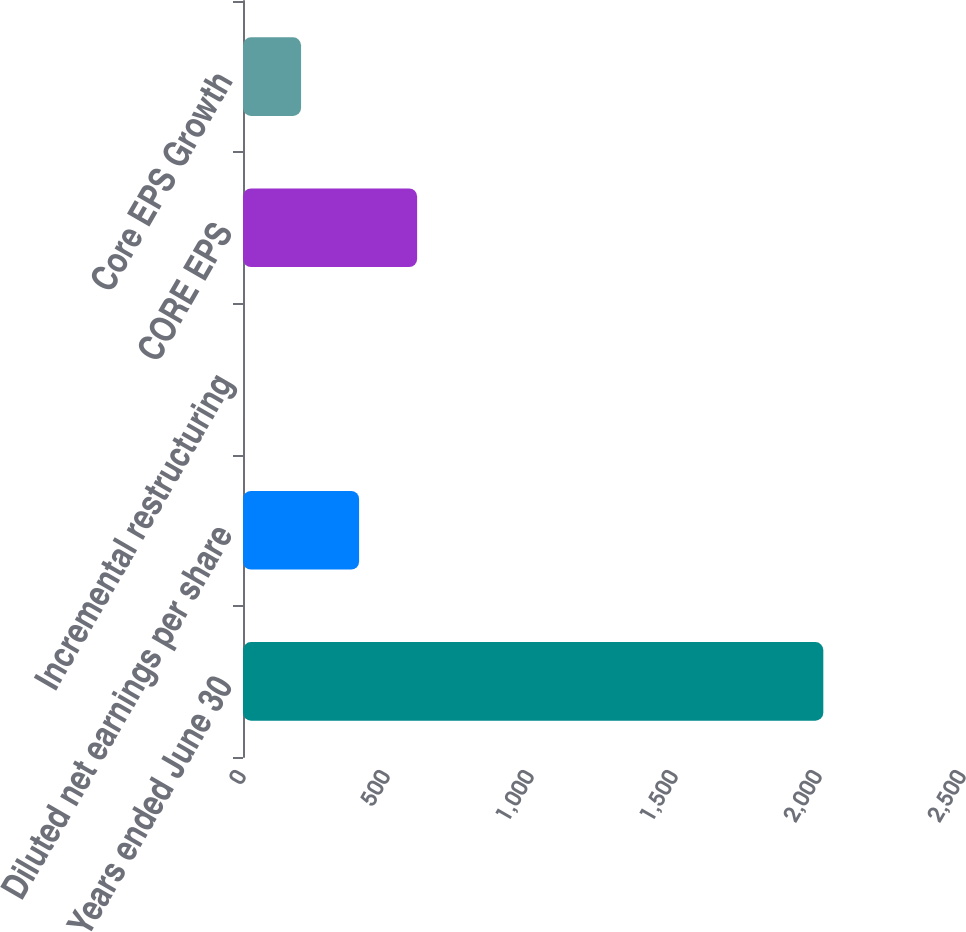Convert chart to OTSL. <chart><loc_0><loc_0><loc_500><loc_500><bar_chart><fcel>Years ended June 30<fcel>Diluted net earnings per share<fcel>Incremental restructuring<fcel>CORE EPS<fcel>Core EPS Growth<nl><fcel>2015<fcel>403.13<fcel>0.17<fcel>604.61<fcel>201.65<nl></chart> 